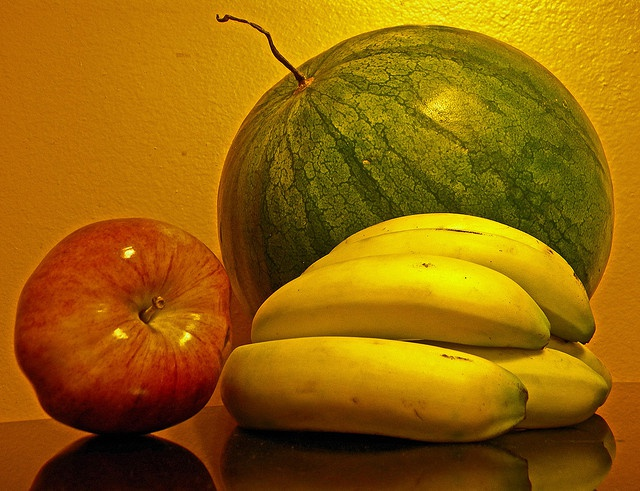Describe the objects in this image and their specific colors. I can see banana in red, olive, orange, gold, and maroon tones, apple in red, maroon, and black tones, and dining table in red, black, maroon, and brown tones in this image. 